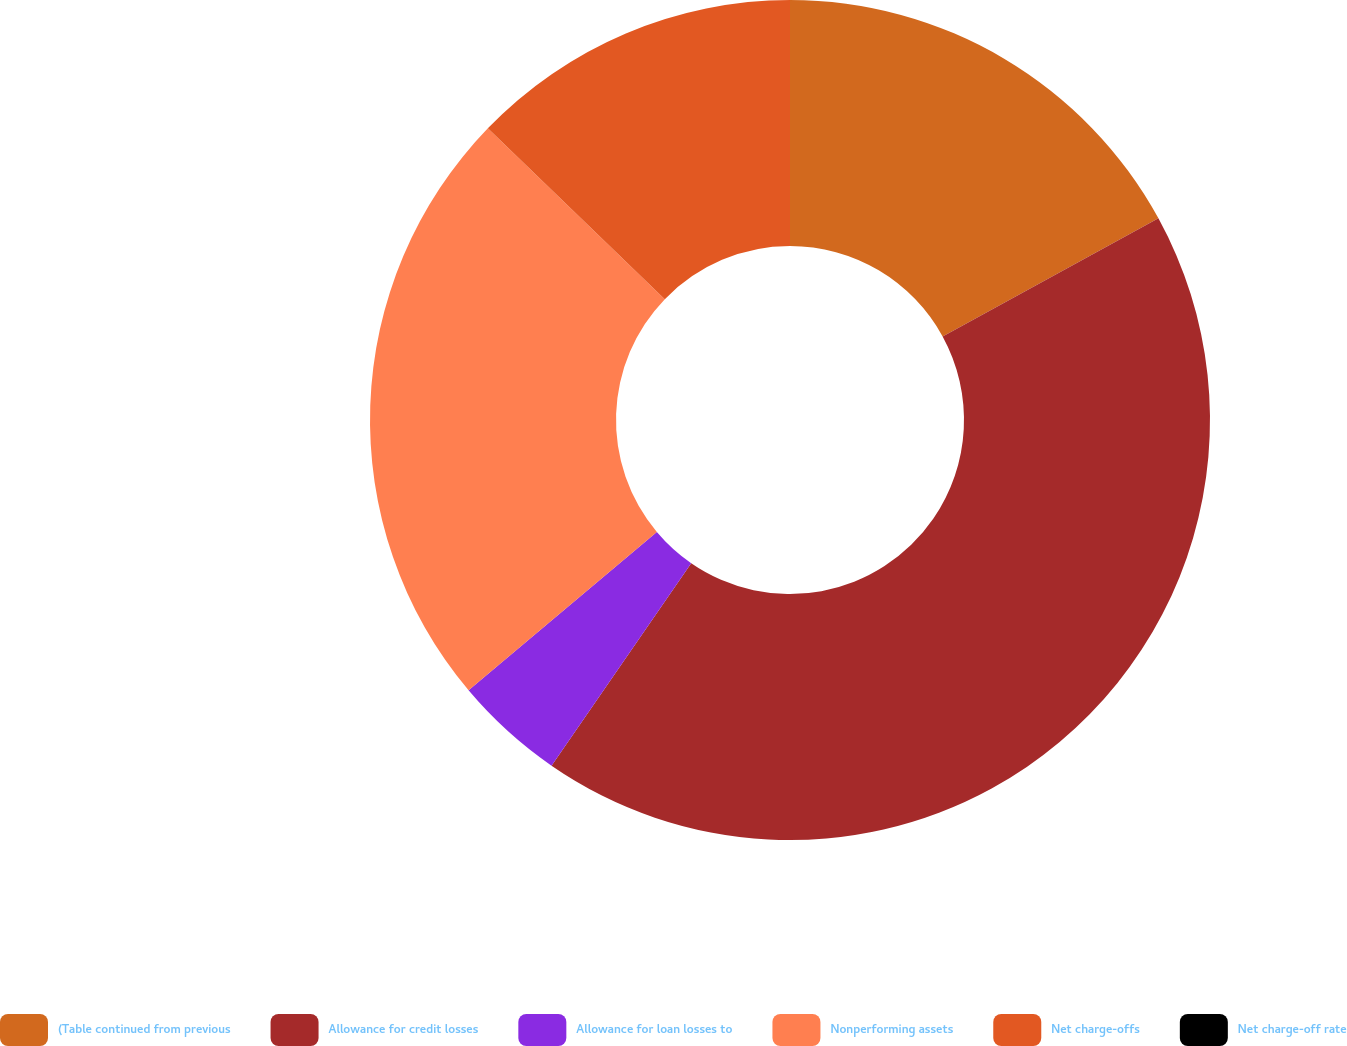Convert chart. <chart><loc_0><loc_0><loc_500><loc_500><pie_chart><fcel>(Table continued from previous<fcel>Allowance for credit losses<fcel>Allowance for loan losses to<fcel>Nonperforming assets<fcel>Net charge-offs<fcel>Net charge-off rate<nl><fcel>17.03%<fcel>42.58%<fcel>4.26%<fcel>23.35%<fcel>12.78%<fcel>0.0%<nl></chart> 